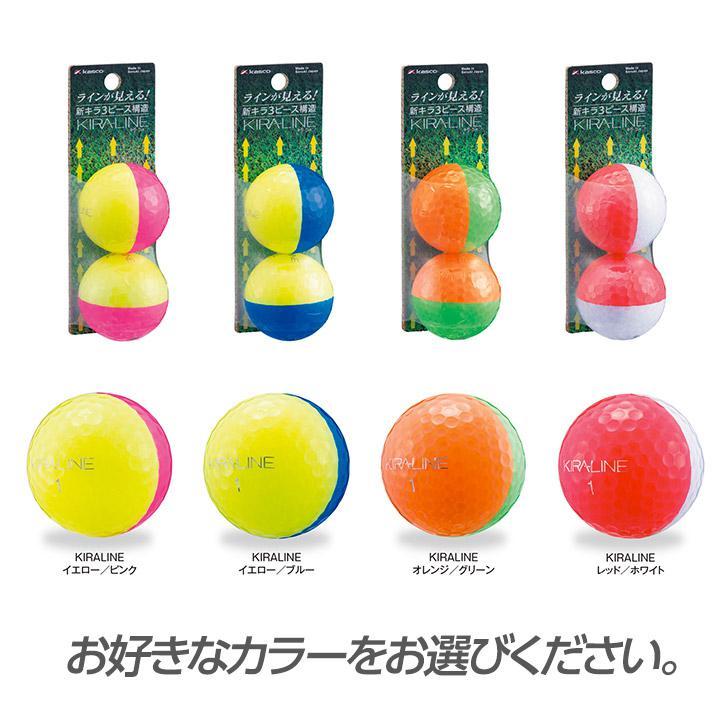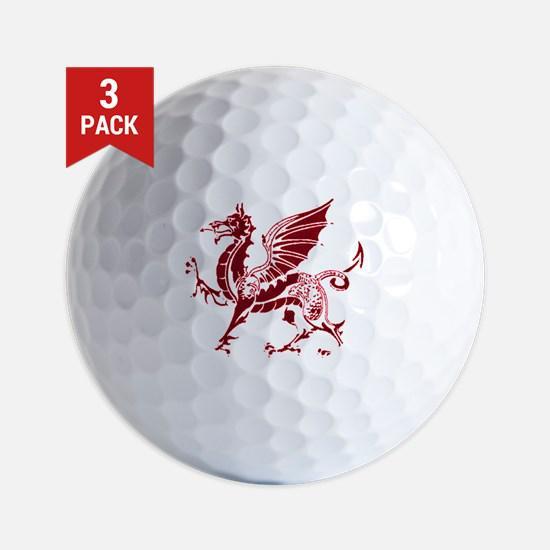The first image is the image on the left, the second image is the image on the right. For the images shown, is this caption "There are exactly two golf balls painted with half of one color and half of another color." true? Answer yes or no. No. The first image is the image on the left, the second image is the image on the right. Considering the images on both sides, is "Atleast one image has a pure white ball" valid? Answer yes or no. Yes. 